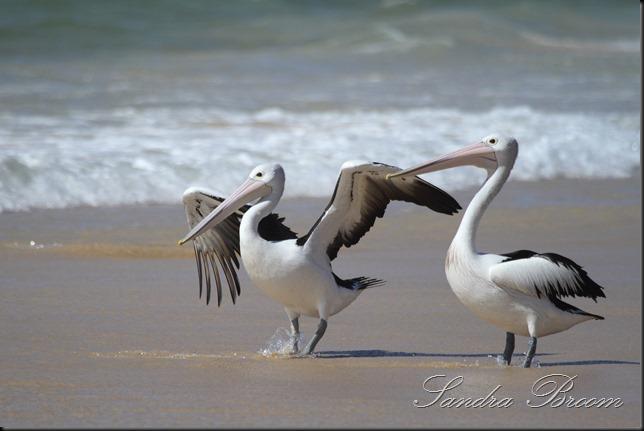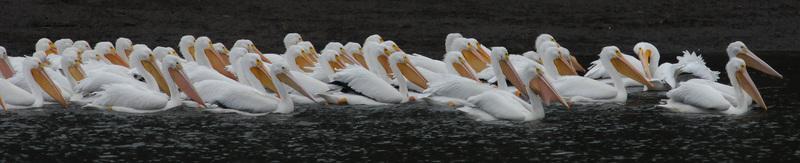The first image is the image on the left, the second image is the image on the right. For the images displayed, is the sentence "The bird in the right image is eating a fish." factually correct? Answer yes or no. No. The first image is the image on the left, the second image is the image on the right. For the images shown, is this caption "At least one of the birds has a fish in its mouth." true? Answer yes or no. No. 